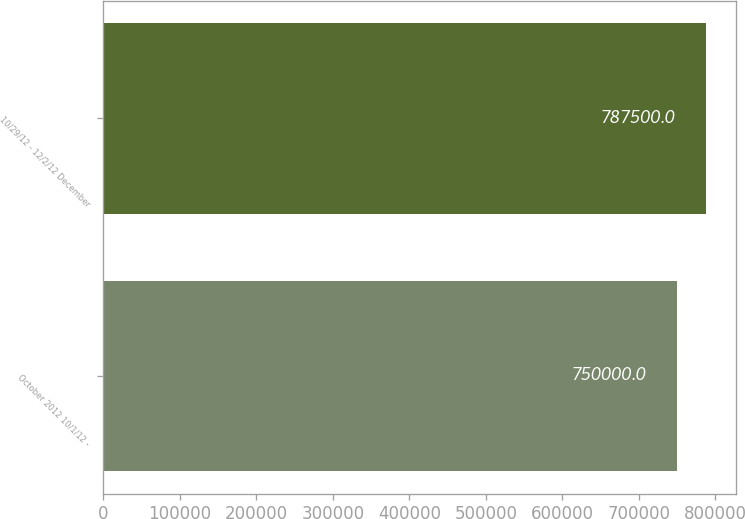Convert chart. <chart><loc_0><loc_0><loc_500><loc_500><bar_chart><fcel>October 2012 10/1/12 -<fcel>10/29/12 - 12/2/12 December<nl><fcel>750000<fcel>787500<nl></chart> 